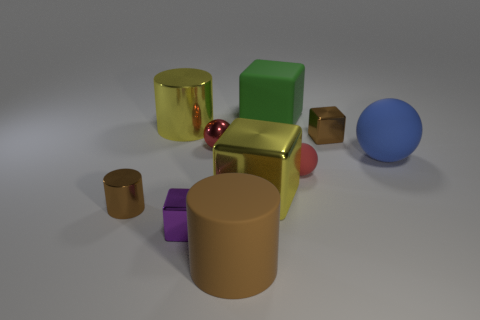Subtract all brown blocks. How many blocks are left? 3 Subtract all metallic cylinders. How many cylinders are left? 1 Subtract all red blocks. Subtract all blue cylinders. How many blocks are left? 4 Subtract all cylinders. How many objects are left? 7 Subtract all matte spheres. Subtract all shiny cylinders. How many objects are left? 6 Add 4 small cylinders. How many small cylinders are left? 5 Add 6 green shiny balls. How many green shiny balls exist? 6 Subtract 0 green cylinders. How many objects are left? 10 